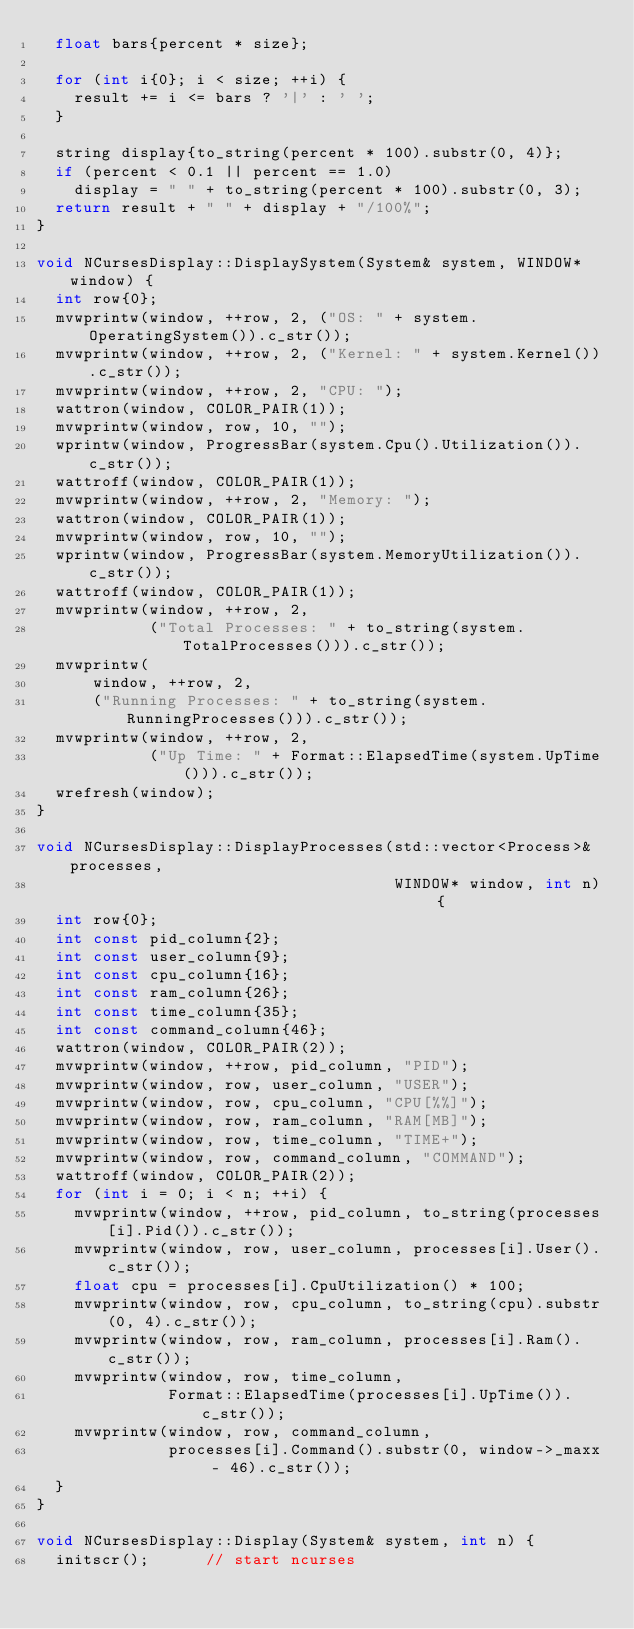Convert code to text. <code><loc_0><loc_0><loc_500><loc_500><_C++_>  float bars{percent * size};

  for (int i{0}; i < size; ++i) {
    result += i <= bars ? '|' : ' ';
  }

  string display{to_string(percent * 100).substr(0, 4)};
  if (percent < 0.1 || percent == 1.0)
    display = " " + to_string(percent * 100).substr(0, 3);
  return result + " " + display + "/100%";
}

void NCursesDisplay::DisplaySystem(System& system, WINDOW* window) {
  int row{0};
  mvwprintw(window, ++row, 2, ("OS: " + system.OperatingSystem()).c_str());
  mvwprintw(window, ++row, 2, ("Kernel: " + system.Kernel()).c_str());
  mvwprintw(window, ++row, 2, "CPU: ");
  wattron(window, COLOR_PAIR(1));
  mvwprintw(window, row, 10, "");
  wprintw(window, ProgressBar(system.Cpu().Utilization()).c_str());
  wattroff(window, COLOR_PAIR(1));
  mvwprintw(window, ++row, 2, "Memory: ");
  wattron(window, COLOR_PAIR(1));
  mvwprintw(window, row, 10, "");
  wprintw(window, ProgressBar(system.MemoryUtilization()).c_str());
  wattroff(window, COLOR_PAIR(1));
  mvwprintw(window, ++row, 2,
            ("Total Processes: " + to_string(system.TotalProcesses())).c_str());
  mvwprintw(
      window, ++row, 2,
      ("Running Processes: " + to_string(system.RunningProcesses())).c_str());
  mvwprintw(window, ++row, 2,
            ("Up Time: " + Format::ElapsedTime(system.UpTime())).c_str());
  wrefresh(window);
}

void NCursesDisplay::DisplayProcesses(std::vector<Process>& processes,
                                      WINDOW* window, int n) {
  int row{0};
  int const pid_column{2};
  int const user_column{9};
  int const cpu_column{16};
  int const ram_column{26};
  int const time_column{35};
  int const command_column{46};
  wattron(window, COLOR_PAIR(2));
  mvwprintw(window, ++row, pid_column, "PID");
  mvwprintw(window, row, user_column, "USER");
  mvwprintw(window, row, cpu_column, "CPU[%%]");
  mvwprintw(window, row, ram_column, "RAM[MB]");
  mvwprintw(window, row, time_column, "TIME+");
  mvwprintw(window, row, command_column, "COMMAND");
  wattroff(window, COLOR_PAIR(2));
  for (int i = 0; i < n; ++i) {
    mvwprintw(window, ++row, pid_column, to_string(processes[i].Pid()).c_str());
    mvwprintw(window, row, user_column, processes[i].User().c_str());
    float cpu = processes[i].CpuUtilization() * 100;
    mvwprintw(window, row, cpu_column, to_string(cpu).substr(0, 4).c_str());
    mvwprintw(window, row, ram_column, processes[i].Ram().c_str());
    mvwprintw(window, row, time_column,
              Format::ElapsedTime(processes[i].UpTime()).c_str());
    mvwprintw(window, row, command_column,
              processes[i].Command().substr(0, window->_maxx - 46).c_str());
  }
}

void NCursesDisplay::Display(System& system, int n) {
  initscr();      // start ncurses</code> 